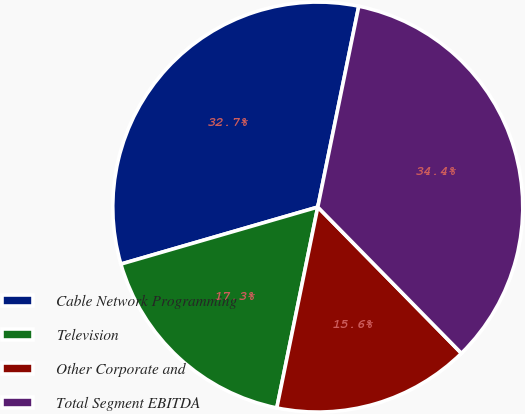Convert chart. <chart><loc_0><loc_0><loc_500><loc_500><pie_chart><fcel>Cable Network Programming<fcel>Television<fcel>Other Corporate and<fcel>Total Segment EBITDA<nl><fcel>32.69%<fcel>17.31%<fcel>15.56%<fcel>34.44%<nl></chart> 